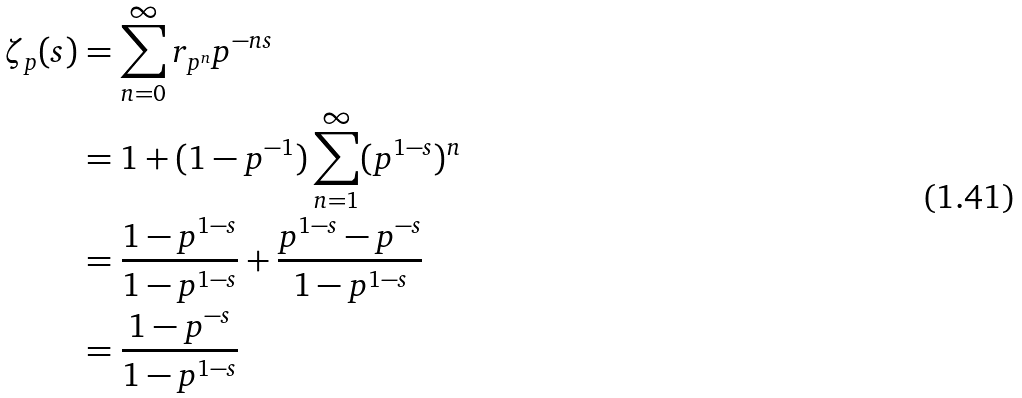<formula> <loc_0><loc_0><loc_500><loc_500>\zeta _ { p } ( s ) & = \sum _ { n = 0 } ^ { \infty } r _ { p ^ { n } } p ^ { - n s } \\ & = 1 + ( 1 - p ^ { - 1 } ) \sum _ { n = 1 } ^ { \infty } ( p ^ { 1 - s } ) ^ { n } \\ & = \frac { 1 - p ^ { 1 - s } } { 1 - p ^ { 1 - s } } + \frac { p ^ { 1 - s } - p ^ { - s } } { 1 - p ^ { 1 - s } } \\ & = \frac { 1 - p ^ { - s } } { 1 - p ^ { 1 - s } }</formula> 